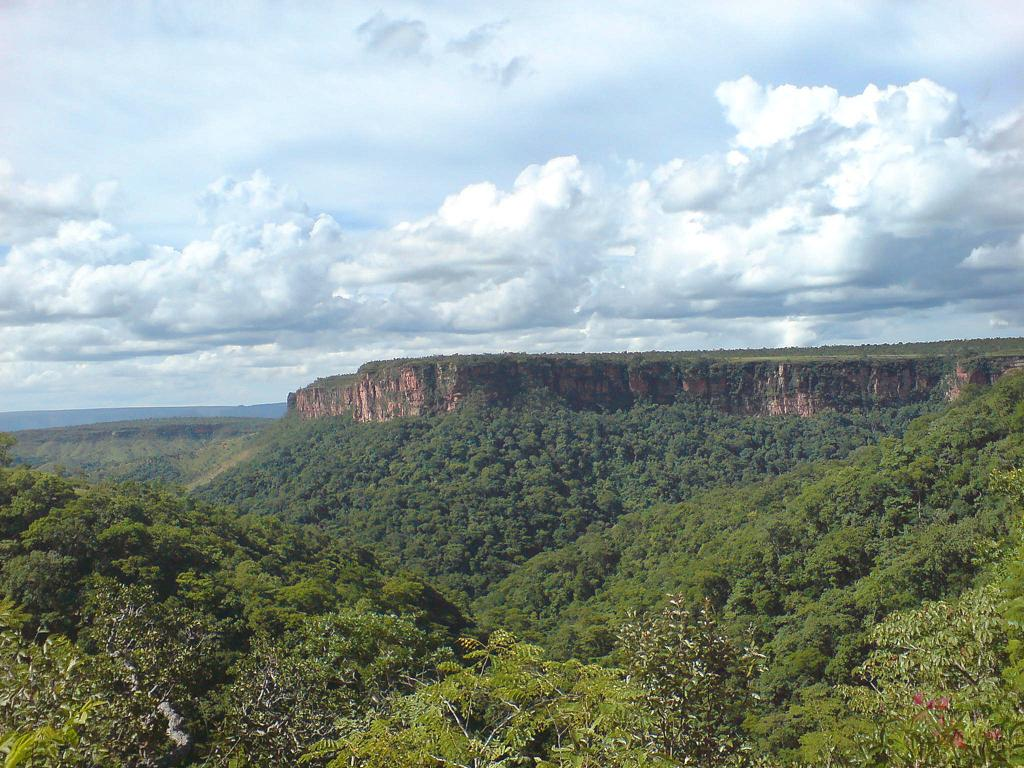What type of natural environment is depicted in the image? The image features many trees and mountains, indicating a natural environment. Can you describe the sky in the image? The sky is visible in the image, and there are many clouds present. What type of terrain can be seen in the image? The presence of trees and mountains suggests a hilly or mountainous terrain. What type of office furniture is visible in the image? There is no office furniture present in the image, as it features a natural environment with trees, mountains, clouds, and sky. What type of cloth is draped over the trees in the image? There is no cloth draped over the trees in the image; the trees are not covered or adorned in any way. 